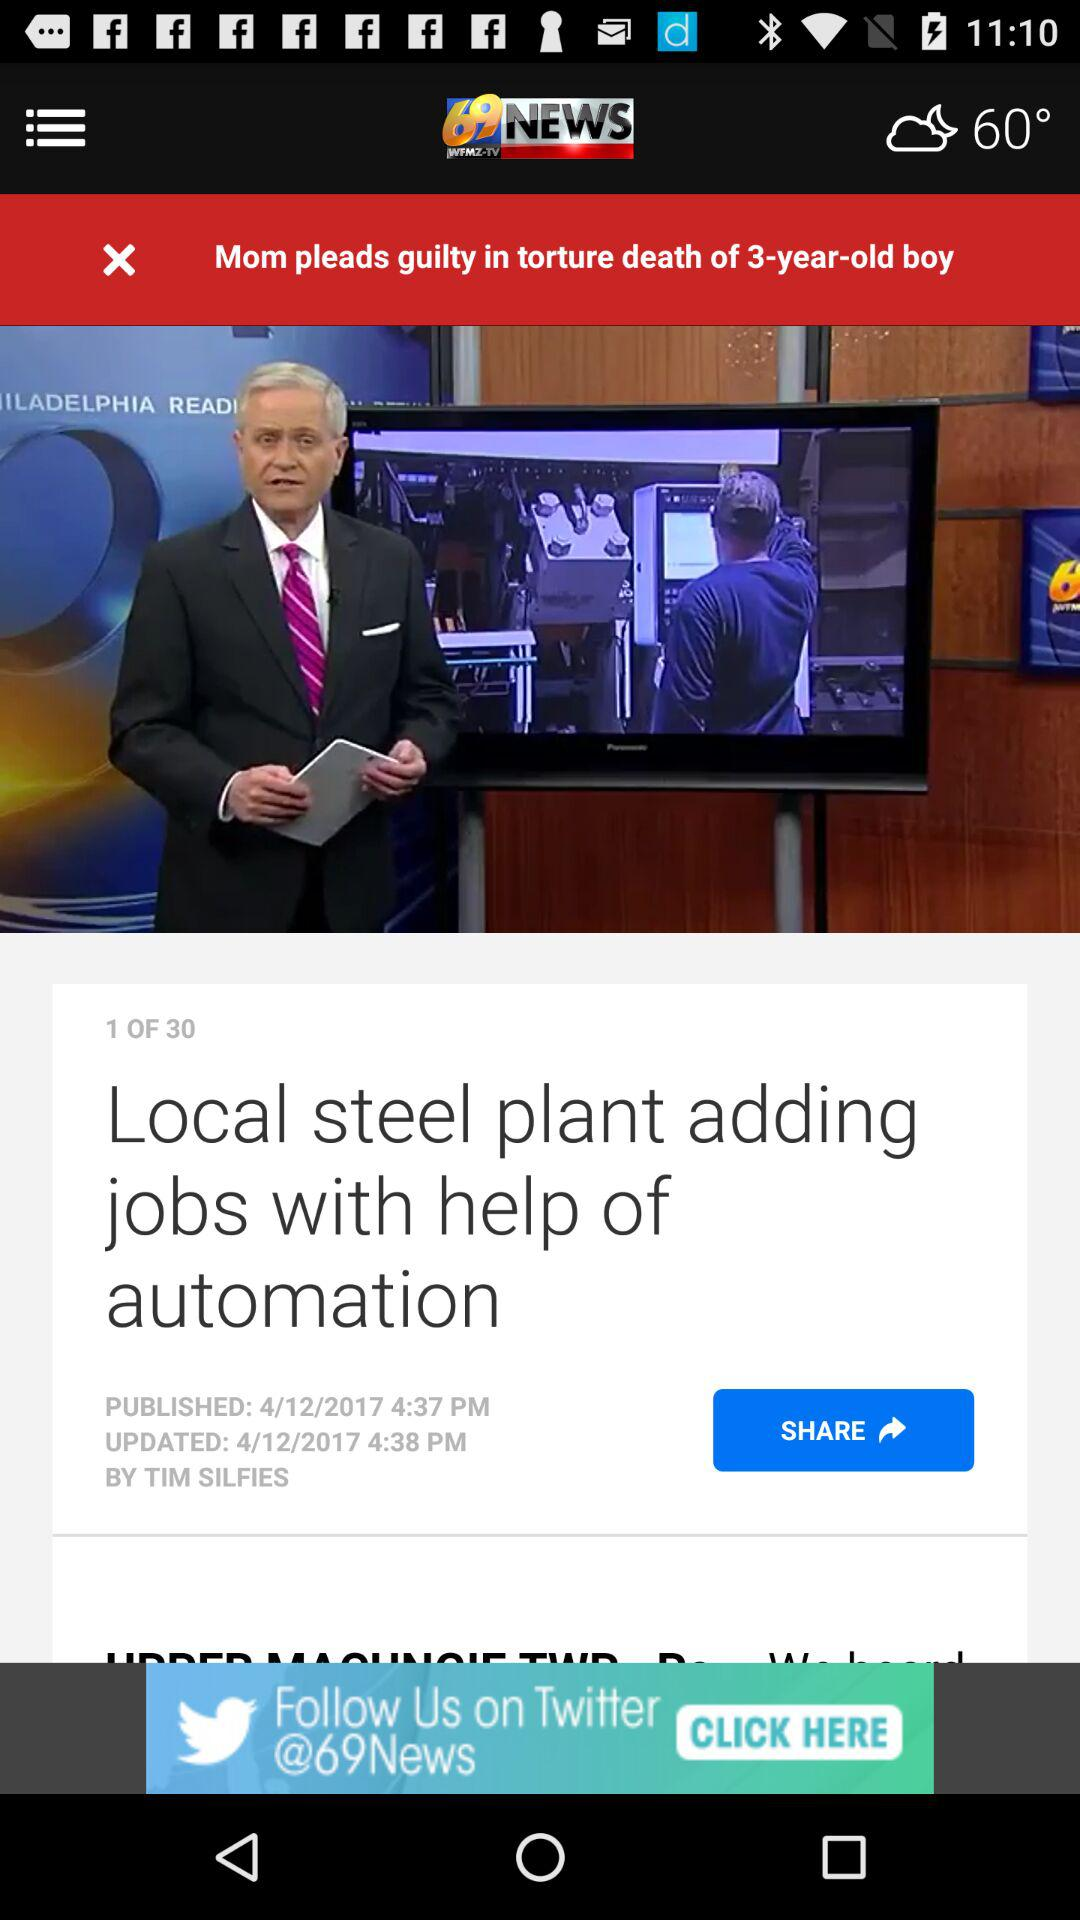Who published the news about the local steel plant adding jobs with help of automation? The news was published by Tim Silfies. 